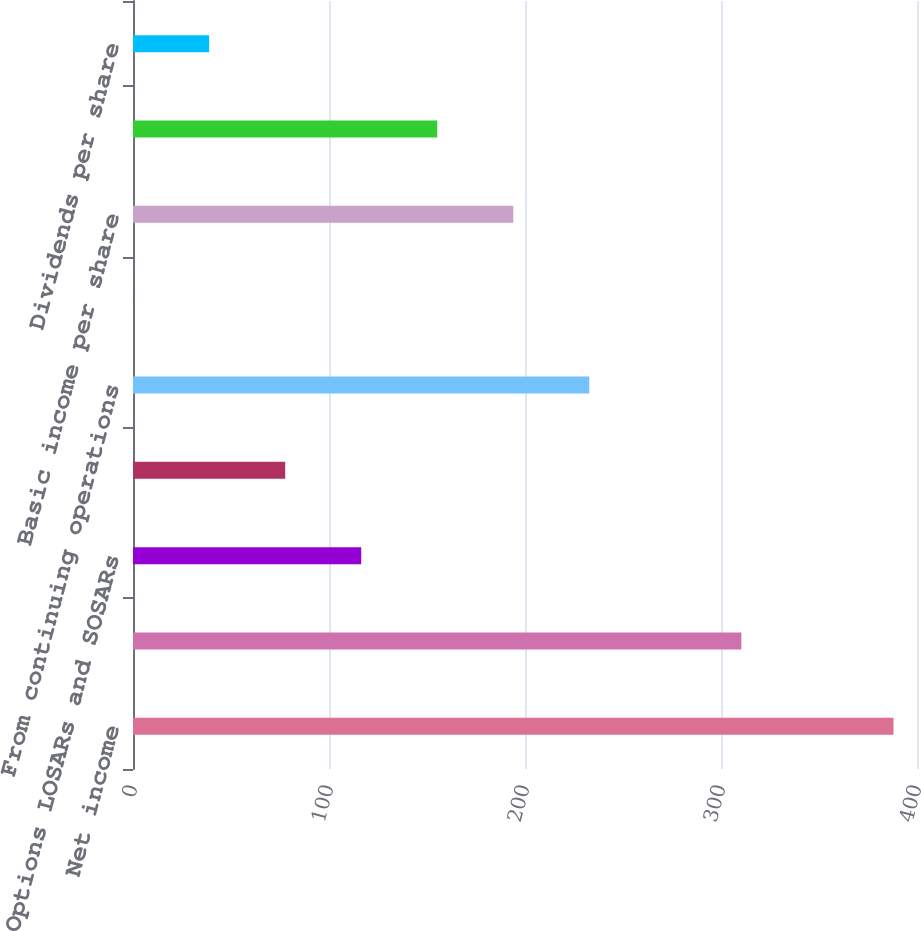Convert chart. <chart><loc_0><loc_0><loc_500><loc_500><bar_chart><fcel>Net income<fcel>Weighted average shares for<fcel>Options LOSARs and SOSARs<fcel>RSUs and DSUs<fcel>From continuing operations<fcel>From discontinued operations<fcel>Basic income per share<fcel>Diluted income per share<fcel>Dividends per share<nl><fcel>388<fcel>310.39<fcel>116.44<fcel>77.65<fcel>232.81<fcel>0.07<fcel>194.02<fcel>155.23<fcel>38.86<nl></chart> 